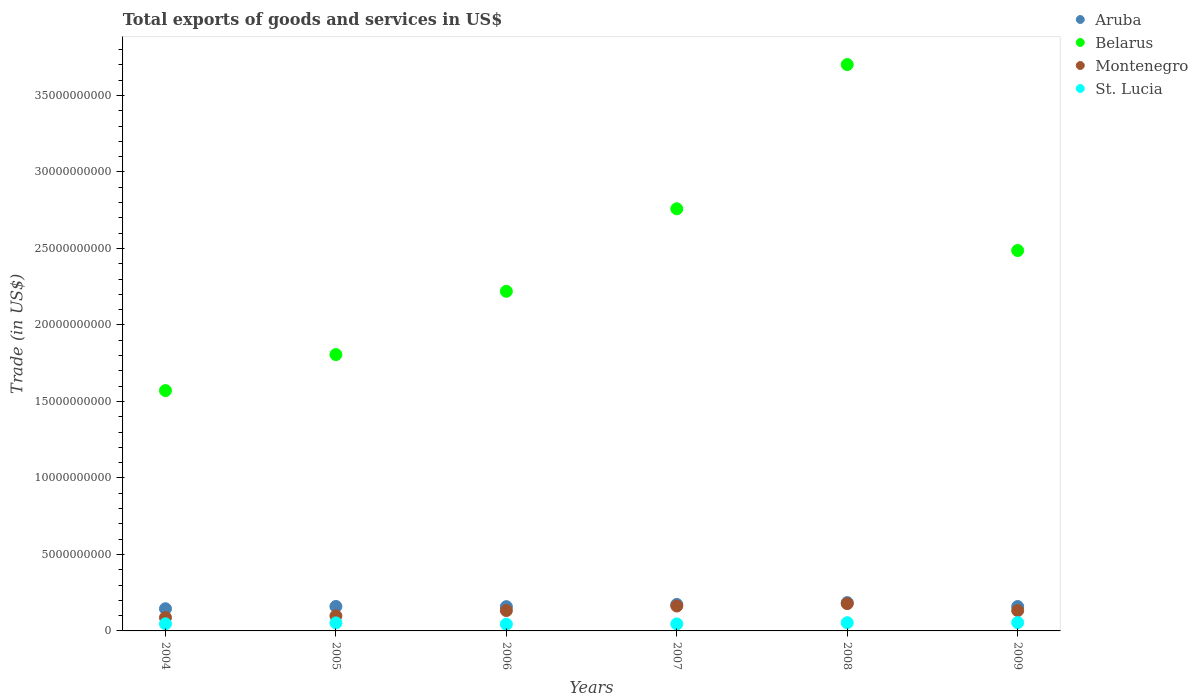Is the number of dotlines equal to the number of legend labels?
Your answer should be very brief. Yes. What is the total exports of goods and services in St. Lucia in 2007?
Provide a succinct answer. 4.57e+08. Across all years, what is the maximum total exports of goods and services in Belarus?
Offer a very short reply. 3.70e+1. Across all years, what is the minimum total exports of goods and services in Aruba?
Your answer should be very brief. 1.45e+09. In which year was the total exports of goods and services in Montenegro minimum?
Give a very brief answer. 2004. What is the total total exports of goods and services in Aruba in the graph?
Give a very brief answer. 9.81e+09. What is the difference between the total exports of goods and services in St. Lucia in 2006 and that in 2007?
Provide a succinct answer. -1.69e+07. What is the difference between the total exports of goods and services in Montenegro in 2006 and the total exports of goods and services in Belarus in 2005?
Keep it short and to the point. -1.67e+1. What is the average total exports of goods and services in Belarus per year?
Offer a very short reply. 2.42e+1. In the year 2006, what is the difference between the total exports of goods and services in Belarus and total exports of goods and services in Aruba?
Offer a terse response. 2.06e+1. In how many years, is the total exports of goods and services in Aruba greater than 29000000000 US$?
Give a very brief answer. 0. What is the ratio of the total exports of goods and services in Aruba in 2005 to that in 2007?
Offer a terse response. 0.92. Is the total exports of goods and services in Montenegro in 2004 less than that in 2009?
Provide a succinct answer. Yes. What is the difference between the highest and the second highest total exports of goods and services in Belarus?
Your answer should be compact. 9.43e+09. What is the difference between the highest and the lowest total exports of goods and services in Aruba?
Your response must be concise. 4.00e+08. In how many years, is the total exports of goods and services in St. Lucia greater than the average total exports of goods and services in St. Lucia taken over all years?
Make the answer very short. 3. Is it the case that in every year, the sum of the total exports of goods and services in Belarus and total exports of goods and services in Aruba  is greater than the total exports of goods and services in St. Lucia?
Offer a very short reply. Yes. Is the total exports of goods and services in St. Lucia strictly less than the total exports of goods and services in Montenegro over the years?
Your response must be concise. Yes. What is the difference between two consecutive major ticks on the Y-axis?
Make the answer very short. 5.00e+09. Are the values on the major ticks of Y-axis written in scientific E-notation?
Provide a short and direct response. No. Does the graph contain any zero values?
Give a very brief answer. No. Does the graph contain grids?
Your answer should be compact. No. What is the title of the graph?
Make the answer very short. Total exports of goods and services in US$. What is the label or title of the X-axis?
Offer a terse response. Years. What is the label or title of the Y-axis?
Give a very brief answer. Trade (in US$). What is the Trade (in US$) in Aruba in 2004?
Your answer should be very brief. 1.45e+09. What is the Trade (in US$) in Belarus in 2004?
Ensure brevity in your answer.  1.57e+1. What is the Trade (in US$) of Montenegro in 2004?
Your response must be concise. 8.71e+08. What is the Trade (in US$) of St. Lucia in 2004?
Keep it short and to the point. 4.64e+08. What is the Trade (in US$) in Aruba in 2005?
Make the answer very short. 1.60e+09. What is the Trade (in US$) in Belarus in 2005?
Your answer should be very brief. 1.81e+1. What is the Trade (in US$) of Montenegro in 2005?
Offer a terse response. 9.83e+08. What is the Trade (in US$) in St. Lucia in 2005?
Provide a succinct answer. 5.25e+08. What is the Trade (in US$) in Aruba in 2006?
Keep it short and to the point. 1.59e+09. What is the Trade (in US$) of Belarus in 2006?
Provide a succinct answer. 2.22e+1. What is the Trade (in US$) in Montenegro in 2006?
Ensure brevity in your answer.  1.33e+09. What is the Trade (in US$) of St. Lucia in 2006?
Offer a terse response. 4.40e+08. What is the Trade (in US$) of Aruba in 2007?
Keep it short and to the point. 1.73e+09. What is the Trade (in US$) of Belarus in 2007?
Ensure brevity in your answer.  2.76e+1. What is the Trade (in US$) of Montenegro in 2007?
Offer a terse response. 1.63e+09. What is the Trade (in US$) of St. Lucia in 2007?
Your answer should be compact. 4.57e+08. What is the Trade (in US$) of Aruba in 2008?
Provide a short and direct response. 1.85e+09. What is the Trade (in US$) in Belarus in 2008?
Your response must be concise. 3.70e+1. What is the Trade (in US$) in Montenegro in 2008?
Your answer should be very brief. 1.78e+09. What is the Trade (in US$) in St. Lucia in 2008?
Offer a very short reply. 5.36e+08. What is the Trade (in US$) of Aruba in 2009?
Make the answer very short. 1.59e+09. What is the Trade (in US$) in Belarus in 2009?
Give a very brief answer. 2.49e+1. What is the Trade (in US$) in Montenegro in 2009?
Your answer should be very brief. 1.33e+09. What is the Trade (in US$) in St. Lucia in 2009?
Your response must be concise. 5.44e+08. Across all years, what is the maximum Trade (in US$) of Aruba?
Your response must be concise. 1.85e+09. Across all years, what is the maximum Trade (in US$) in Belarus?
Keep it short and to the point. 3.70e+1. Across all years, what is the maximum Trade (in US$) in Montenegro?
Your response must be concise. 1.78e+09. Across all years, what is the maximum Trade (in US$) in St. Lucia?
Offer a terse response. 5.44e+08. Across all years, what is the minimum Trade (in US$) of Aruba?
Make the answer very short. 1.45e+09. Across all years, what is the minimum Trade (in US$) in Belarus?
Your answer should be very brief. 1.57e+1. Across all years, what is the minimum Trade (in US$) in Montenegro?
Offer a very short reply. 8.71e+08. Across all years, what is the minimum Trade (in US$) of St. Lucia?
Keep it short and to the point. 4.40e+08. What is the total Trade (in US$) of Aruba in the graph?
Keep it short and to the point. 9.81e+09. What is the total Trade (in US$) in Belarus in the graph?
Ensure brevity in your answer.  1.45e+11. What is the total Trade (in US$) of Montenegro in the graph?
Provide a short and direct response. 7.93e+09. What is the total Trade (in US$) of St. Lucia in the graph?
Your answer should be compact. 2.97e+09. What is the difference between the Trade (in US$) in Aruba in 2004 and that in 2005?
Offer a terse response. -1.48e+08. What is the difference between the Trade (in US$) of Belarus in 2004 and that in 2005?
Your answer should be compact. -2.35e+09. What is the difference between the Trade (in US$) in Montenegro in 2004 and that in 2005?
Provide a succinct answer. -1.12e+08. What is the difference between the Trade (in US$) of St. Lucia in 2004 and that in 2005?
Keep it short and to the point. -6.07e+07. What is the difference between the Trade (in US$) of Aruba in 2004 and that in 2006?
Keep it short and to the point. -1.36e+08. What is the difference between the Trade (in US$) of Belarus in 2004 and that in 2006?
Provide a succinct answer. -6.49e+09. What is the difference between the Trade (in US$) of Montenegro in 2004 and that in 2006?
Your answer should be very brief. -4.60e+08. What is the difference between the Trade (in US$) in St. Lucia in 2004 and that in 2006?
Keep it short and to the point. 2.40e+07. What is the difference between the Trade (in US$) of Aruba in 2004 and that in 2007?
Your answer should be compact. -2.79e+08. What is the difference between the Trade (in US$) in Belarus in 2004 and that in 2007?
Your answer should be compact. -1.19e+1. What is the difference between the Trade (in US$) in Montenegro in 2004 and that in 2007?
Make the answer very short. -7.58e+08. What is the difference between the Trade (in US$) of St. Lucia in 2004 and that in 2007?
Make the answer very short. 7.11e+06. What is the difference between the Trade (in US$) of Aruba in 2004 and that in 2008?
Make the answer very short. -4.00e+08. What is the difference between the Trade (in US$) of Belarus in 2004 and that in 2008?
Offer a very short reply. -2.13e+1. What is the difference between the Trade (in US$) in Montenegro in 2004 and that in 2008?
Make the answer very short. -9.13e+08. What is the difference between the Trade (in US$) in St. Lucia in 2004 and that in 2008?
Ensure brevity in your answer.  -7.18e+07. What is the difference between the Trade (in US$) in Aruba in 2004 and that in 2009?
Your answer should be compact. -1.44e+08. What is the difference between the Trade (in US$) in Belarus in 2004 and that in 2009?
Your answer should be very brief. -9.16e+09. What is the difference between the Trade (in US$) of Montenegro in 2004 and that in 2009?
Your response must be concise. -4.59e+08. What is the difference between the Trade (in US$) in St. Lucia in 2004 and that in 2009?
Ensure brevity in your answer.  -7.97e+07. What is the difference between the Trade (in US$) in Belarus in 2005 and that in 2006?
Your response must be concise. -4.13e+09. What is the difference between the Trade (in US$) of Montenegro in 2005 and that in 2006?
Ensure brevity in your answer.  -3.48e+08. What is the difference between the Trade (in US$) of St. Lucia in 2005 and that in 2006?
Provide a short and direct response. 8.47e+07. What is the difference between the Trade (in US$) of Aruba in 2005 and that in 2007?
Offer a very short reply. -1.32e+08. What is the difference between the Trade (in US$) of Belarus in 2005 and that in 2007?
Keep it short and to the point. -9.53e+09. What is the difference between the Trade (in US$) in Montenegro in 2005 and that in 2007?
Give a very brief answer. -6.46e+08. What is the difference between the Trade (in US$) of St. Lucia in 2005 and that in 2007?
Your answer should be very brief. 6.78e+07. What is the difference between the Trade (in US$) in Aruba in 2005 and that in 2008?
Your answer should be very brief. -2.52e+08. What is the difference between the Trade (in US$) in Belarus in 2005 and that in 2008?
Your answer should be compact. -1.90e+1. What is the difference between the Trade (in US$) in Montenegro in 2005 and that in 2008?
Offer a terse response. -8.01e+08. What is the difference between the Trade (in US$) in St. Lucia in 2005 and that in 2008?
Offer a very short reply. -1.11e+07. What is the difference between the Trade (in US$) of Aruba in 2005 and that in 2009?
Offer a very short reply. 3.88e+06. What is the difference between the Trade (in US$) of Belarus in 2005 and that in 2009?
Give a very brief answer. -6.80e+09. What is the difference between the Trade (in US$) of Montenegro in 2005 and that in 2009?
Your response must be concise. -3.47e+08. What is the difference between the Trade (in US$) in St. Lucia in 2005 and that in 2009?
Your response must be concise. -1.90e+07. What is the difference between the Trade (in US$) in Aruba in 2006 and that in 2007?
Ensure brevity in your answer.  -1.44e+08. What is the difference between the Trade (in US$) in Belarus in 2006 and that in 2007?
Make the answer very short. -5.39e+09. What is the difference between the Trade (in US$) in Montenegro in 2006 and that in 2007?
Your answer should be compact. -2.98e+08. What is the difference between the Trade (in US$) in St. Lucia in 2006 and that in 2007?
Provide a short and direct response. -1.69e+07. What is the difference between the Trade (in US$) in Aruba in 2006 and that in 2008?
Your answer should be compact. -2.64e+08. What is the difference between the Trade (in US$) of Belarus in 2006 and that in 2008?
Offer a very short reply. -1.48e+1. What is the difference between the Trade (in US$) of Montenegro in 2006 and that in 2008?
Your answer should be compact. -4.53e+08. What is the difference between the Trade (in US$) of St. Lucia in 2006 and that in 2008?
Make the answer very short. -9.59e+07. What is the difference between the Trade (in US$) of Aruba in 2006 and that in 2009?
Your answer should be very brief. -8.12e+06. What is the difference between the Trade (in US$) of Belarus in 2006 and that in 2009?
Provide a succinct answer. -2.67e+09. What is the difference between the Trade (in US$) in Montenegro in 2006 and that in 2009?
Offer a terse response. 8.57e+05. What is the difference between the Trade (in US$) in St. Lucia in 2006 and that in 2009?
Give a very brief answer. -1.04e+08. What is the difference between the Trade (in US$) of Aruba in 2007 and that in 2008?
Offer a terse response. -1.21e+08. What is the difference between the Trade (in US$) of Belarus in 2007 and that in 2008?
Keep it short and to the point. -9.43e+09. What is the difference between the Trade (in US$) in Montenegro in 2007 and that in 2008?
Offer a terse response. -1.56e+08. What is the difference between the Trade (in US$) of St. Lucia in 2007 and that in 2008?
Offer a terse response. -7.89e+07. What is the difference between the Trade (in US$) in Aruba in 2007 and that in 2009?
Your answer should be compact. 1.35e+08. What is the difference between the Trade (in US$) in Belarus in 2007 and that in 2009?
Make the answer very short. 2.73e+09. What is the difference between the Trade (in US$) in Montenegro in 2007 and that in 2009?
Your answer should be very brief. 2.99e+08. What is the difference between the Trade (in US$) of St. Lucia in 2007 and that in 2009?
Provide a short and direct response. -8.68e+07. What is the difference between the Trade (in US$) of Aruba in 2008 and that in 2009?
Keep it short and to the point. 2.56e+08. What is the difference between the Trade (in US$) in Belarus in 2008 and that in 2009?
Offer a terse response. 1.22e+1. What is the difference between the Trade (in US$) of Montenegro in 2008 and that in 2009?
Your answer should be very brief. 4.54e+08. What is the difference between the Trade (in US$) in St. Lucia in 2008 and that in 2009?
Offer a terse response. -7.89e+06. What is the difference between the Trade (in US$) in Aruba in 2004 and the Trade (in US$) in Belarus in 2005?
Offer a very short reply. -1.66e+1. What is the difference between the Trade (in US$) in Aruba in 2004 and the Trade (in US$) in Montenegro in 2005?
Offer a terse response. 4.67e+08. What is the difference between the Trade (in US$) in Aruba in 2004 and the Trade (in US$) in St. Lucia in 2005?
Offer a terse response. 9.25e+08. What is the difference between the Trade (in US$) of Belarus in 2004 and the Trade (in US$) of Montenegro in 2005?
Offer a very short reply. 1.47e+1. What is the difference between the Trade (in US$) in Belarus in 2004 and the Trade (in US$) in St. Lucia in 2005?
Your answer should be compact. 1.52e+1. What is the difference between the Trade (in US$) of Montenegro in 2004 and the Trade (in US$) of St. Lucia in 2005?
Ensure brevity in your answer.  3.46e+08. What is the difference between the Trade (in US$) in Aruba in 2004 and the Trade (in US$) in Belarus in 2006?
Offer a very short reply. -2.07e+1. What is the difference between the Trade (in US$) in Aruba in 2004 and the Trade (in US$) in Montenegro in 2006?
Your answer should be compact. 1.19e+08. What is the difference between the Trade (in US$) in Aruba in 2004 and the Trade (in US$) in St. Lucia in 2006?
Provide a succinct answer. 1.01e+09. What is the difference between the Trade (in US$) in Belarus in 2004 and the Trade (in US$) in Montenegro in 2006?
Your answer should be very brief. 1.44e+1. What is the difference between the Trade (in US$) of Belarus in 2004 and the Trade (in US$) of St. Lucia in 2006?
Your response must be concise. 1.53e+1. What is the difference between the Trade (in US$) of Montenegro in 2004 and the Trade (in US$) of St. Lucia in 2006?
Offer a very short reply. 4.31e+08. What is the difference between the Trade (in US$) in Aruba in 2004 and the Trade (in US$) in Belarus in 2007?
Your answer should be compact. -2.61e+1. What is the difference between the Trade (in US$) in Aruba in 2004 and the Trade (in US$) in Montenegro in 2007?
Ensure brevity in your answer.  -1.79e+08. What is the difference between the Trade (in US$) of Aruba in 2004 and the Trade (in US$) of St. Lucia in 2007?
Ensure brevity in your answer.  9.93e+08. What is the difference between the Trade (in US$) in Belarus in 2004 and the Trade (in US$) in Montenegro in 2007?
Give a very brief answer. 1.41e+1. What is the difference between the Trade (in US$) in Belarus in 2004 and the Trade (in US$) in St. Lucia in 2007?
Your answer should be very brief. 1.53e+1. What is the difference between the Trade (in US$) of Montenegro in 2004 and the Trade (in US$) of St. Lucia in 2007?
Give a very brief answer. 4.14e+08. What is the difference between the Trade (in US$) of Aruba in 2004 and the Trade (in US$) of Belarus in 2008?
Give a very brief answer. -3.56e+1. What is the difference between the Trade (in US$) in Aruba in 2004 and the Trade (in US$) in Montenegro in 2008?
Your answer should be very brief. -3.34e+08. What is the difference between the Trade (in US$) in Aruba in 2004 and the Trade (in US$) in St. Lucia in 2008?
Provide a short and direct response. 9.14e+08. What is the difference between the Trade (in US$) of Belarus in 2004 and the Trade (in US$) of Montenegro in 2008?
Your answer should be compact. 1.39e+1. What is the difference between the Trade (in US$) in Belarus in 2004 and the Trade (in US$) in St. Lucia in 2008?
Offer a terse response. 1.52e+1. What is the difference between the Trade (in US$) in Montenegro in 2004 and the Trade (in US$) in St. Lucia in 2008?
Offer a terse response. 3.35e+08. What is the difference between the Trade (in US$) in Aruba in 2004 and the Trade (in US$) in Belarus in 2009?
Keep it short and to the point. -2.34e+1. What is the difference between the Trade (in US$) of Aruba in 2004 and the Trade (in US$) of Montenegro in 2009?
Keep it short and to the point. 1.20e+08. What is the difference between the Trade (in US$) in Aruba in 2004 and the Trade (in US$) in St. Lucia in 2009?
Make the answer very short. 9.06e+08. What is the difference between the Trade (in US$) of Belarus in 2004 and the Trade (in US$) of Montenegro in 2009?
Offer a very short reply. 1.44e+1. What is the difference between the Trade (in US$) in Belarus in 2004 and the Trade (in US$) in St. Lucia in 2009?
Provide a short and direct response. 1.52e+1. What is the difference between the Trade (in US$) of Montenegro in 2004 and the Trade (in US$) of St. Lucia in 2009?
Ensure brevity in your answer.  3.27e+08. What is the difference between the Trade (in US$) of Aruba in 2005 and the Trade (in US$) of Belarus in 2006?
Make the answer very short. -2.06e+1. What is the difference between the Trade (in US$) of Aruba in 2005 and the Trade (in US$) of Montenegro in 2006?
Give a very brief answer. 2.67e+08. What is the difference between the Trade (in US$) of Aruba in 2005 and the Trade (in US$) of St. Lucia in 2006?
Your answer should be very brief. 1.16e+09. What is the difference between the Trade (in US$) in Belarus in 2005 and the Trade (in US$) in Montenegro in 2006?
Offer a terse response. 1.67e+1. What is the difference between the Trade (in US$) of Belarus in 2005 and the Trade (in US$) of St. Lucia in 2006?
Ensure brevity in your answer.  1.76e+1. What is the difference between the Trade (in US$) of Montenegro in 2005 and the Trade (in US$) of St. Lucia in 2006?
Provide a succinct answer. 5.43e+08. What is the difference between the Trade (in US$) in Aruba in 2005 and the Trade (in US$) in Belarus in 2007?
Offer a very short reply. -2.60e+1. What is the difference between the Trade (in US$) of Aruba in 2005 and the Trade (in US$) of Montenegro in 2007?
Offer a terse response. -3.09e+07. What is the difference between the Trade (in US$) in Aruba in 2005 and the Trade (in US$) in St. Lucia in 2007?
Your response must be concise. 1.14e+09. What is the difference between the Trade (in US$) of Belarus in 2005 and the Trade (in US$) of Montenegro in 2007?
Your answer should be very brief. 1.64e+1. What is the difference between the Trade (in US$) of Belarus in 2005 and the Trade (in US$) of St. Lucia in 2007?
Provide a succinct answer. 1.76e+1. What is the difference between the Trade (in US$) in Montenegro in 2005 and the Trade (in US$) in St. Lucia in 2007?
Provide a short and direct response. 5.26e+08. What is the difference between the Trade (in US$) of Aruba in 2005 and the Trade (in US$) of Belarus in 2008?
Your answer should be compact. -3.54e+1. What is the difference between the Trade (in US$) of Aruba in 2005 and the Trade (in US$) of Montenegro in 2008?
Keep it short and to the point. -1.87e+08. What is the difference between the Trade (in US$) of Aruba in 2005 and the Trade (in US$) of St. Lucia in 2008?
Keep it short and to the point. 1.06e+09. What is the difference between the Trade (in US$) of Belarus in 2005 and the Trade (in US$) of Montenegro in 2008?
Offer a very short reply. 1.63e+1. What is the difference between the Trade (in US$) of Belarus in 2005 and the Trade (in US$) of St. Lucia in 2008?
Your response must be concise. 1.75e+1. What is the difference between the Trade (in US$) of Montenegro in 2005 and the Trade (in US$) of St. Lucia in 2008?
Provide a short and direct response. 4.47e+08. What is the difference between the Trade (in US$) of Aruba in 2005 and the Trade (in US$) of Belarus in 2009?
Provide a succinct answer. -2.33e+1. What is the difference between the Trade (in US$) in Aruba in 2005 and the Trade (in US$) in Montenegro in 2009?
Your answer should be compact. 2.68e+08. What is the difference between the Trade (in US$) in Aruba in 2005 and the Trade (in US$) in St. Lucia in 2009?
Give a very brief answer. 1.05e+09. What is the difference between the Trade (in US$) of Belarus in 2005 and the Trade (in US$) of Montenegro in 2009?
Offer a very short reply. 1.67e+1. What is the difference between the Trade (in US$) of Belarus in 2005 and the Trade (in US$) of St. Lucia in 2009?
Give a very brief answer. 1.75e+1. What is the difference between the Trade (in US$) of Montenegro in 2005 and the Trade (in US$) of St. Lucia in 2009?
Ensure brevity in your answer.  4.39e+08. What is the difference between the Trade (in US$) of Aruba in 2006 and the Trade (in US$) of Belarus in 2007?
Offer a terse response. -2.60e+1. What is the difference between the Trade (in US$) in Aruba in 2006 and the Trade (in US$) in Montenegro in 2007?
Your answer should be compact. -4.29e+07. What is the difference between the Trade (in US$) of Aruba in 2006 and the Trade (in US$) of St. Lucia in 2007?
Make the answer very short. 1.13e+09. What is the difference between the Trade (in US$) of Belarus in 2006 and the Trade (in US$) of Montenegro in 2007?
Give a very brief answer. 2.06e+1. What is the difference between the Trade (in US$) of Belarus in 2006 and the Trade (in US$) of St. Lucia in 2007?
Your answer should be very brief. 2.17e+1. What is the difference between the Trade (in US$) in Montenegro in 2006 and the Trade (in US$) in St. Lucia in 2007?
Provide a short and direct response. 8.74e+08. What is the difference between the Trade (in US$) in Aruba in 2006 and the Trade (in US$) in Belarus in 2008?
Make the answer very short. -3.54e+1. What is the difference between the Trade (in US$) of Aruba in 2006 and the Trade (in US$) of Montenegro in 2008?
Offer a terse response. -1.99e+08. What is the difference between the Trade (in US$) of Aruba in 2006 and the Trade (in US$) of St. Lucia in 2008?
Your answer should be very brief. 1.05e+09. What is the difference between the Trade (in US$) in Belarus in 2006 and the Trade (in US$) in Montenegro in 2008?
Your answer should be compact. 2.04e+1. What is the difference between the Trade (in US$) in Belarus in 2006 and the Trade (in US$) in St. Lucia in 2008?
Provide a short and direct response. 2.17e+1. What is the difference between the Trade (in US$) of Montenegro in 2006 and the Trade (in US$) of St. Lucia in 2008?
Your answer should be compact. 7.95e+08. What is the difference between the Trade (in US$) of Aruba in 2006 and the Trade (in US$) of Belarus in 2009?
Offer a very short reply. -2.33e+1. What is the difference between the Trade (in US$) in Aruba in 2006 and the Trade (in US$) in Montenegro in 2009?
Give a very brief answer. 2.56e+08. What is the difference between the Trade (in US$) in Aruba in 2006 and the Trade (in US$) in St. Lucia in 2009?
Provide a succinct answer. 1.04e+09. What is the difference between the Trade (in US$) in Belarus in 2006 and the Trade (in US$) in Montenegro in 2009?
Offer a terse response. 2.09e+1. What is the difference between the Trade (in US$) of Belarus in 2006 and the Trade (in US$) of St. Lucia in 2009?
Give a very brief answer. 2.17e+1. What is the difference between the Trade (in US$) of Montenegro in 2006 and the Trade (in US$) of St. Lucia in 2009?
Provide a short and direct response. 7.87e+08. What is the difference between the Trade (in US$) of Aruba in 2007 and the Trade (in US$) of Belarus in 2008?
Your answer should be very brief. -3.53e+1. What is the difference between the Trade (in US$) of Aruba in 2007 and the Trade (in US$) of Montenegro in 2008?
Your response must be concise. -5.50e+07. What is the difference between the Trade (in US$) of Aruba in 2007 and the Trade (in US$) of St. Lucia in 2008?
Your answer should be very brief. 1.19e+09. What is the difference between the Trade (in US$) in Belarus in 2007 and the Trade (in US$) in Montenegro in 2008?
Give a very brief answer. 2.58e+1. What is the difference between the Trade (in US$) in Belarus in 2007 and the Trade (in US$) in St. Lucia in 2008?
Offer a terse response. 2.71e+1. What is the difference between the Trade (in US$) in Montenegro in 2007 and the Trade (in US$) in St. Lucia in 2008?
Make the answer very short. 1.09e+09. What is the difference between the Trade (in US$) in Aruba in 2007 and the Trade (in US$) in Belarus in 2009?
Keep it short and to the point. -2.31e+1. What is the difference between the Trade (in US$) of Aruba in 2007 and the Trade (in US$) of Montenegro in 2009?
Offer a very short reply. 3.99e+08. What is the difference between the Trade (in US$) in Aruba in 2007 and the Trade (in US$) in St. Lucia in 2009?
Ensure brevity in your answer.  1.19e+09. What is the difference between the Trade (in US$) in Belarus in 2007 and the Trade (in US$) in Montenegro in 2009?
Your response must be concise. 2.63e+1. What is the difference between the Trade (in US$) of Belarus in 2007 and the Trade (in US$) of St. Lucia in 2009?
Keep it short and to the point. 2.70e+1. What is the difference between the Trade (in US$) in Montenegro in 2007 and the Trade (in US$) in St. Lucia in 2009?
Your answer should be compact. 1.08e+09. What is the difference between the Trade (in US$) of Aruba in 2008 and the Trade (in US$) of Belarus in 2009?
Your answer should be very brief. -2.30e+1. What is the difference between the Trade (in US$) in Aruba in 2008 and the Trade (in US$) in Montenegro in 2009?
Your answer should be compact. 5.20e+08. What is the difference between the Trade (in US$) in Aruba in 2008 and the Trade (in US$) in St. Lucia in 2009?
Your answer should be compact. 1.31e+09. What is the difference between the Trade (in US$) in Belarus in 2008 and the Trade (in US$) in Montenegro in 2009?
Keep it short and to the point. 3.57e+1. What is the difference between the Trade (in US$) in Belarus in 2008 and the Trade (in US$) in St. Lucia in 2009?
Your answer should be compact. 3.65e+1. What is the difference between the Trade (in US$) in Montenegro in 2008 and the Trade (in US$) in St. Lucia in 2009?
Your answer should be very brief. 1.24e+09. What is the average Trade (in US$) of Aruba per year?
Offer a very short reply. 1.63e+09. What is the average Trade (in US$) in Belarus per year?
Make the answer very short. 2.42e+1. What is the average Trade (in US$) of Montenegro per year?
Offer a very short reply. 1.32e+09. What is the average Trade (in US$) of St. Lucia per year?
Provide a short and direct response. 4.94e+08. In the year 2004, what is the difference between the Trade (in US$) in Aruba and Trade (in US$) in Belarus?
Offer a terse response. -1.43e+1. In the year 2004, what is the difference between the Trade (in US$) in Aruba and Trade (in US$) in Montenegro?
Your answer should be compact. 5.79e+08. In the year 2004, what is the difference between the Trade (in US$) of Aruba and Trade (in US$) of St. Lucia?
Your response must be concise. 9.86e+08. In the year 2004, what is the difference between the Trade (in US$) in Belarus and Trade (in US$) in Montenegro?
Your answer should be compact. 1.48e+1. In the year 2004, what is the difference between the Trade (in US$) of Belarus and Trade (in US$) of St. Lucia?
Your answer should be compact. 1.52e+1. In the year 2004, what is the difference between the Trade (in US$) in Montenegro and Trade (in US$) in St. Lucia?
Keep it short and to the point. 4.07e+08. In the year 2005, what is the difference between the Trade (in US$) in Aruba and Trade (in US$) in Belarus?
Offer a very short reply. -1.65e+1. In the year 2005, what is the difference between the Trade (in US$) of Aruba and Trade (in US$) of Montenegro?
Your answer should be very brief. 6.15e+08. In the year 2005, what is the difference between the Trade (in US$) of Aruba and Trade (in US$) of St. Lucia?
Your answer should be very brief. 1.07e+09. In the year 2005, what is the difference between the Trade (in US$) in Belarus and Trade (in US$) in Montenegro?
Make the answer very short. 1.71e+1. In the year 2005, what is the difference between the Trade (in US$) in Belarus and Trade (in US$) in St. Lucia?
Offer a terse response. 1.75e+1. In the year 2005, what is the difference between the Trade (in US$) in Montenegro and Trade (in US$) in St. Lucia?
Your answer should be very brief. 4.58e+08. In the year 2006, what is the difference between the Trade (in US$) in Aruba and Trade (in US$) in Belarus?
Your answer should be very brief. -2.06e+1. In the year 2006, what is the difference between the Trade (in US$) in Aruba and Trade (in US$) in Montenegro?
Make the answer very short. 2.55e+08. In the year 2006, what is the difference between the Trade (in US$) in Aruba and Trade (in US$) in St. Lucia?
Give a very brief answer. 1.15e+09. In the year 2006, what is the difference between the Trade (in US$) in Belarus and Trade (in US$) in Montenegro?
Your answer should be very brief. 2.09e+1. In the year 2006, what is the difference between the Trade (in US$) of Belarus and Trade (in US$) of St. Lucia?
Ensure brevity in your answer.  2.18e+1. In the year 2006, what is the difference between the Trade (in US$) of Montenegro and Trade (in US$) of St. Lucia?
Offer a very short reply. 8.91e+08. In the year 2007, what is the difference between the Trade (in US$) of Aruba and Trade (in US$) of Belarus?
Your response must be concise. -2.59e+1. In the year 2007, what is the difference between the Trade (in US$) in Aruba and Trade (in US$) in Montenegro?
Your response must be concise. 1.01e+08. In the year 2007, what is the difference between the Trade (in US$) in Aruba and Trade (in US$) in St. Lucia?
Provide a succinct answer. 1.27e+09. In the year 2007, what is the difference between the Trade (in US$) of Belarus and Trade (in US$) of Montenegro?
Offer a terse response. 2.60e+1. In the year 2007, what is the difference between the Trade (in US$) of Belarus and Trade (in US$) of St. Lucia?
Provide a short and direct response. 2.71e+1. In the year 2007, what is the difference between the Trade (in US$) of Montenegro and Trade (in US$) of St. Lucia?
Keep it short and to the point. 1.17e+09. In the year 2008, what is the difference between the Trade (in US$) in Aruba and Trade (in US$) in Belarus?
Give a very brief answer. -3.52e+1. In the year 2008, what is the difference between the Trade (in US$) of Aruba and Trade (in US$) of Montenegro?
Give a very brief answer. 6.56e+07. In the year 2008, what is the difference between the Trade (in US$) in Aruba and Trade (in US$) in St. Lucia?
Give a very brief answer. 1.31e+09. In the year 2008, what is the difference between the Trade (in US$) in Belarus and Trade (in US$) in Montenegro?
Make the answer very short. 3.52e+1. In the year 2008, what is the difference between the Trade (in US$) in Belarus and Trade (in US$) in St. Lucia?
Provide a short and direct response. 3.65e+1. In the year 2008, what is the difference between the Trade (in US$) of Montenegro and Trade (in US$) of St. Lucia?
Your response must be concise. 1.25e+09. In the year 2009, what is the difference between the Trade (in US$) in Aruba and Trade (in US$) in Belarus?
Your answer should be compact. -2.33e+1. In the year 2009, what is the difference between the Trade (in US$) of Aruba and Trade (in US$) of Montenegro?
Your answer should be compact. 2.64e+08. In the year 2009, what is the difference between the Trade (in US$) of Aruba and Trade (in US$) of St. Lucia?
Your answer should be very brief. 1.05e+09. In the year 2009, what is the difference between the Trade (in US$) of Belarus and Trade (in US$) of Montenegro?
Provide a succinct answer. 2.35e+1. In the year 2009, what is the difference between the Trade (in US$) in Belarus and Trade (in US$) in St. Lucia?
Keep it short and to the point. 2.43e+1. In the year 2009, what is the difference between the Trade (in US$) of Montenegro and Trade (in US$) of St. Lucia?
Make the answer very short. 7.86e+08. What is the ratio of the Trade (in US$) of Aruba in 2004 to that in 2005?
Give a very brief answer. 0.91. What is the ratio of the Trade (in US$) of Belarus in 2004 to that in 2005?
Offer a very short reply. 0.87. What is the ratio of the Trade (in US$) of Montenegro in 2004 to that in 2005?
Your response must be concise. 0.89. What is the ratio of the Trade (in US$) of St. Lucia in 2004 to that in 2005?
Make the answer very short. 0.88. What is the ratio of the Trade (in US$) of Aruba in 2004 to that in 2006?
Your answer should be very brief. 0.91. What is the ratio of the Trade (in US$) of Belarus in 2004 to that in 2006?
Provide a succinct answer. 0.71. What is the ratio of the Trade (in US$) in Montenegro in 2004 to that in 2006?
Offer a terse response. 0.65. What is the ratio of the Trade (in US$) in St. Lucia in 2004 to that in 2006?
Give a very brief answer. 1.05. What is the ratio of the Trade (in US$) in Aruba in 2004 to that in 2007?
Offer a very short reply. 0.84. What is the ratio of the Trade (in US$) in Belarus in 2004 to that in 2007?
Give a very brief answer. 0.57. What is the ratio of the Trade (in US$) of Montenegro in 2004 to that in 2007?
Provide a succinct answer. 0.53. What is the ratio of the Trade (in US$) in St. Lucia in 2004 to that in 2007?
Offer a very short reply. 1.02. What is the ratio of the Trade (in US$) of Aruba in 2004 to that in 2008?
Your answer should be compact. 0.78. What is the ratio of the Trade (in US$) of Belarus in 2004 to that in 2008?
Ensure brevity in your answer.  0.42. What is the ratio of the Trade (in US$) of Montenegro in 2004 to that in 2008?
Provide a short and direct response. 0.49. What is the ratio of the Trade (in US$) in St. Lucia in 2004 to that in 2008?
Keep it short and to the point. 0.87. What is the ratio of the Trade (in US$) of Aruba in 2004 to that in 2009?
Your answer should be very brief. 0.91. What is the ratio of the Trade (in US$) in Belarus in 2004 to that in 2009?
Make the answer very short. 0.63. What is the ratio of the Trade (in US$) of Montenegro in 2004 to that in 2009?
Provide a short and direct response. 0.65. What is the ratio of the Trade (in US$) of St. Lucia in 2004 to that in 2009?
Make the answer very short. 0.85. What is the ratio of the Trade (in US$) of Aruba in 2005 to that in 2006?
Make the answer very short. 1.01. What is the ratio of the Trade (in US$) of Belarus in 2005 to that in 2006?
Keep it short and to the point. 0.81. What is the ratio of the Trade (in US$) in Montenegro in 2005 to that in 2006?
Give a very brief answer. 0.74. What is the ratio of the Trade (in US$) of St. Lucia in 2005 to that in 2006?
Make the answer very short. 1.19. What is the ratio of the Trade (in US$) in Aruba in 2005 to that in 2007?
Provide a succinct answer. 0.92. What is the ratio of the Trade (in US$) in Belarus in 2005 to that in 2007?
Ensure brevity in your answer.  0.65. What is the ratio of the Trade (in US$) of Montenegro in 2005 to that in 2007?
Provide a short and direct response. 0.6. What is the ratio of the Trade (in US$) in St. Lucia in 2005 to that in 2007?
Make the answer very short. 1.15. What is the ratio of the Trade (in US$) of Aruba in 2005 to that in 2008?
Keep it short and to the point. 0.86. What is the ratio of the Trade (in US$) in Belarus in 2005 to that in 2008?
Ensure brevity in your answer.  0.49. What is the ratio of the Trade (in US$) of Montenegro in 2005 to that in 2008?
Make the answer very short. 0.55. What is the ratio of the Trade (in US$) of St. Lucia in 2005 to that in 2008?
Make the answer very short. 0.98. What is the ratio of the Trade (in US$) of Aruba in 2005 to that in 2009?
Provide a succinct answer. 1. What is the ratio of the Trade (in US$) of Belarus in 2005 to that in 2009?
Ensure brevity in your answer.  0.73. What is the ratio of the Trade (in US$) in Montenegro in 2005 to that in 2009?
Provide a short and direct response. 0.74. What is the ratio of the Trade (in US$) of St. Lucia in 2005 to that in 2009?
Your response must be concise. 0.96. What is the ratio of the Trade (in US$) in Aruba in 2006 to that in 2007?
Your answer should be very brief. 0.92. What is the ratio of the Trade (in US$) of Belarus in 2006 to that in 2007?
Give a very brief answer. 0.8. What is the ratio of the Trade (in US$) of Montenegro in 2006 to that in 2007?
Give a very brief answer. 0.82. What is the ratio of the Trade (in US$) in St. Lucia in 2006 to that in 2007?
Provide a succinct answer. 0.96. What is the ratio of the Trade (in US$) of Aruba in 2006 to that in 2008?
Provide a succinct answer. 0.86. What is the ratio of the Trade (in US$) in Belarus in 2006 to that in 2008?
Your response must be concise. 0.6. What is the ratio of the Trade (in US$) of Montenegro in 2006 to that in 2008?
Provide a succinct answer. 0.75. What is the ratio of the Trade (in US$) of St. Lucia in 2006 to that in 2008?
Provide a short and direct response. 0.82. What is the ratio of the Trade (in US$) of Aruba in 2006 to that in 2009?
Offer a terse response. 0.99. What is the ratio of the Trade (in US$) of Belarus in 2006 to that in 2009?
Provide a succinct answer. 0.89. What is the ratio of the Trade (in US$) of Montenegro in 2006 to that in 2009?
Ensure brevity in your answer.  1. What is the ratio of the Trade (in US$) in St. Lucia in 2006 to that in 2009?
Give a very brief answer. 0.81. What is the ratio of the Trade (in US$) of Aruba in 2007 to that in 2008?
Your response must be concise. 0.93. What is the ratio of the Trade (in US$) of Belarus in 2007 to that in 2008?
Provide a succinct answer. 0.75. What is the ratio of the Trade (in US$) in Montenegro in 2007 to that in 2008?
Your answer should be compact. 0.91. What is the ratio of the Trade (in US$) in St. Lucia in 2007 to that in 2008?
Provide a succinct answer. 0.85. What is the ratio of the Trade (in US$) of Aruba in 2007 to that in 2009?
Provide a short and direct response. 1.08. What is the ratio of the Trade (in US$) in Belarus in 2007 to that in 2009?
Your response must be concise. 1.11. What is the ratio of the Trade (in US$) in Montenegro in 2007 to that in 2009?
Your answer should be compact. 1.22. What is the ratio of the Trade (in US$) of St. Lucia in 2007 to that in 2009?
Your answer should be compact. 0.84. What is the ratio of the Trade (in US$) in Aruba in 2008 to that in 2009?
Ensure brevity in your answer.  1.16. What is the ratio of the Trade (in US$) of Belarus in 2008 to that in 2009?
Your answer should be very brief. 1.49. What is the ratio of the Trade (in US$) in Montenegro in 2008 to that in 2009?
Provide a short and direct response. 1.34. What is the ratio of the Trade (in US$) of St. Lucia in 2008 to that in 2009?
Provide a short and direct response. 0.99. What is the difference between the highest and the second highest Trade (in US$) of Aruba?
Give a very brief answer. 1.21e+08. What is the difference between the highest and the second highest Trade (in US$) of Belarus?
Give a very brief answer. 9.43e+09. What is the difference between the highest and the second highest Trade (in US$) in Montenegro?
Your response must be concise. 1.56e+08. What is the difference between the highest and the second highest Trade (in US$) in St. Lucia?
Give a very brief answer. 7.89e+06. What is the difference between the highest and the lowest Trade (in US$) in Aruba?
Offer a very short reply. 4.00e+08. What is the difference between the highest and the lowest Trade (in US$) in Belarus?
Your response must be concise. 2.13e+1. What is the difference between the highest and the lowest Trade (in US$) of Montenegro?
Offer a very short reply. 9.13e+08. What is the difference between the highest and the lowest Trade (in US$) of St. Lucia?
Your answer should be very brief. 1.04e+08. 